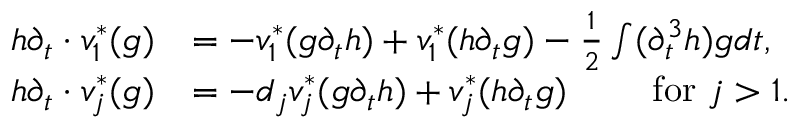<formula> <loc_0><loc_0><loc_500><loc_500>\begin{array} { r l } { h \partial _ { t } \cdot v _ { 1 } ^ { * } ( g ) } & { = - v _ { 1 } ^ { * } ( g \partial _ { t } h ) + v _ { 1 } ^ { * } ( h \partial _ { t } g ) - \frac { 1 } { 2 } \int ( \partial _ { t } ^ { 3 } h ) g d t , } \\ { h \partial _ { t } \cdot v _ { j } ^ { * } ( g ) } & { = - d _ { j } v _ { j } ^ { * } ( g \partial _ { t } h ) + v _ { j } ^ { * } ( h \partial _ { t } g ) \quad f o r j > 1 . } \end{array}</formula> 